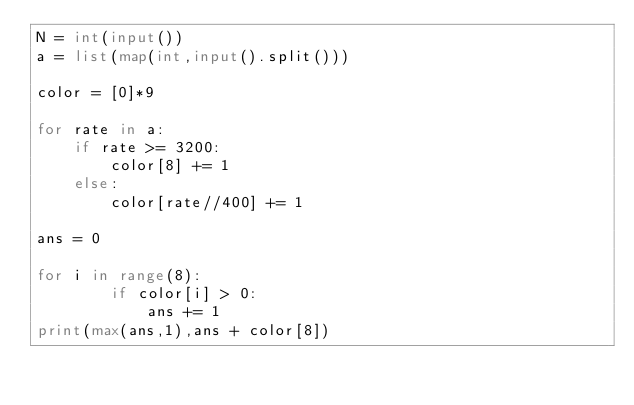Convert code to text. <code><loc_0><loc_0><loc_500><loc_500><_Python_>N = int(input())
a = list(map(int,input().split()))

color = [0]*9

for rate in a:
    if rate >= 3200:
        color[8] += 1
    else:
        color[rate//400] += 1
    
ans = 0

for i in range(8):
        if color[i] > 0:
            ans += 1
print(max(ans,1),ans + color[8])</code> 